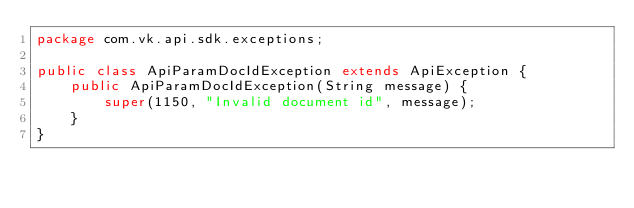Convert code to text. <code><loc_0><loc_0><loc_500><loc_500><_Java_>package com.vk.api.sdk.exceptions;

public class ApiParamDocIdException extends ApiException {
    public ApiParamDocIdException(String message) {
        super(1150, "Invalid document id", message);
    }
}
</code> 